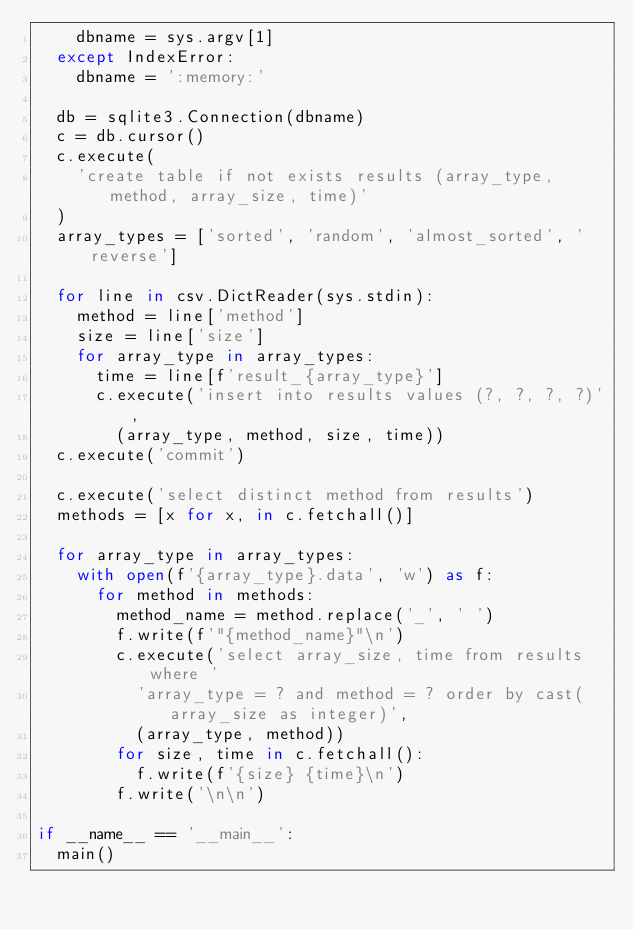<code> <loc_0><loc_0><loc_500><loc_500><_Python_>    dbname = sys.argv[1]
  except IndexError:
    dbname = ':memory:'

  db = sqlite3.Connection(dbname)
  c = db.cursor()
  c.execute(
    'create table if not exists results (array_type, method, array_size, time)'
  )
  array_types = ['sorted', 'random', 'almost_sorted', 'reverse']

  for line in csv.DictReader(sys.stdin):
    method = line['method']
    size = line['size']
    for array_type in array_types:
      time = line[f'result_{array_type}']
      c.execute('insert into results values (?, ?, ?, ?)',
        (array_type, method, size, time))
  c.execute('commit')

  c.execute('select distinct method from results')
  methods = [x for x, in c.fetchall()]

  for array_type in array_types:
    with open(f'{array_type}.data', 'w') as f:
      for method in methods:
        method_name = method.replace('_', ' ')
        f.write(f'"{method_name}"\n')
        c.execute('select array_size, time from results where '
          'array_type = ? and method = ? order by cast(array_size as integer)',
          (array_type, method))
        for size, time in c.fetchall():
          f.write(f'{size} {time}\n')
        f.write('\n\n')

if __name__ == '__main__':
  main()
</code> 